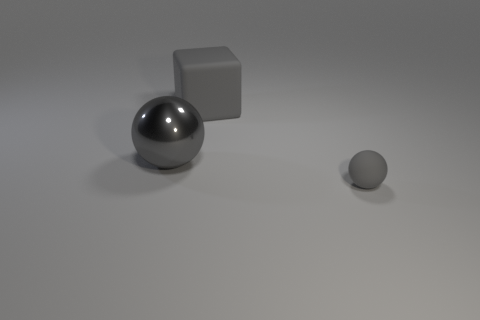What number of spheres are small brown things or small objects?
Keep it short and to the point. 1. What is the color of the tiny rubber thing that is in front of the big gray object that is left of the block?
Offer a very short reply. Gray. What shape is the small gray rubber object?
Your answer should be compact. Sphere. There is a rubber object that is behind the gray rubber ball; is its size the same as the tiny gray ball?
Offer a terse response. No. Is there a small object made of the same material as the tiny gray sphere?
Offer a very short reply. No. How many things are either things that are behind the small rubber ball or small objects?
Your answer should be very brief. 3. Is there a small cyan matte object?
Offer a very short reply. No. There is a object that is on the right side of the gray shiny object and behind the tiny gray rubber ball; what shape is it?
Your response must be concise. Cube. There is a gray object that is in front of the large ball; what size is it?
Make the answer very short. Small. Do the rubber thing to the left of the small sphere and the large shiny ball have the same color?
Give a very brief answer. Yes. 